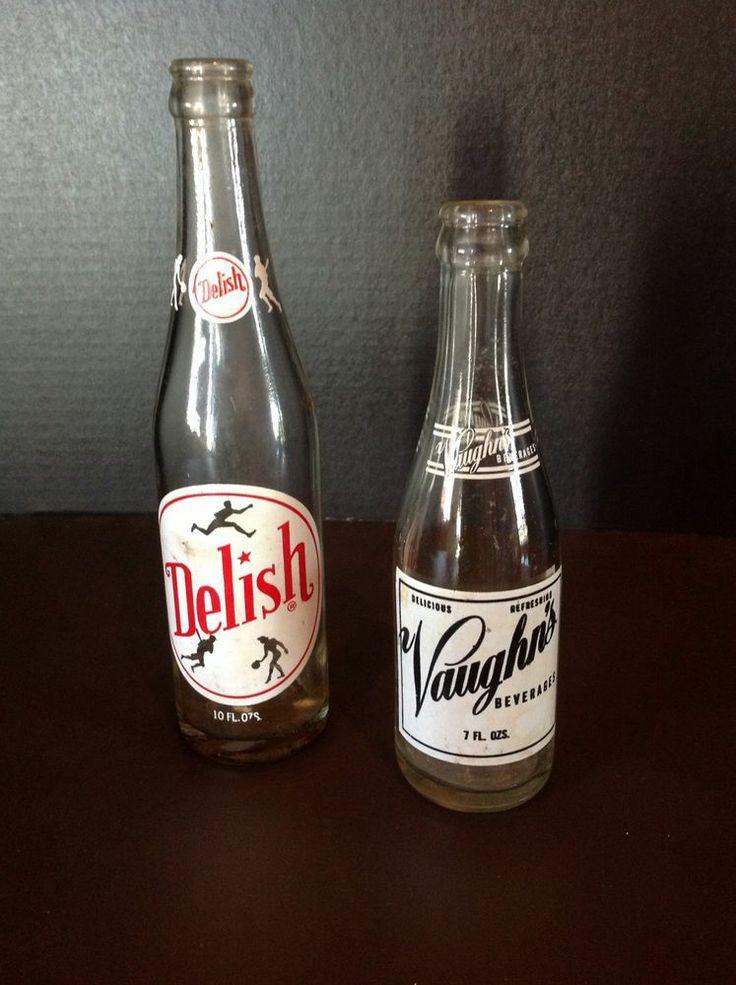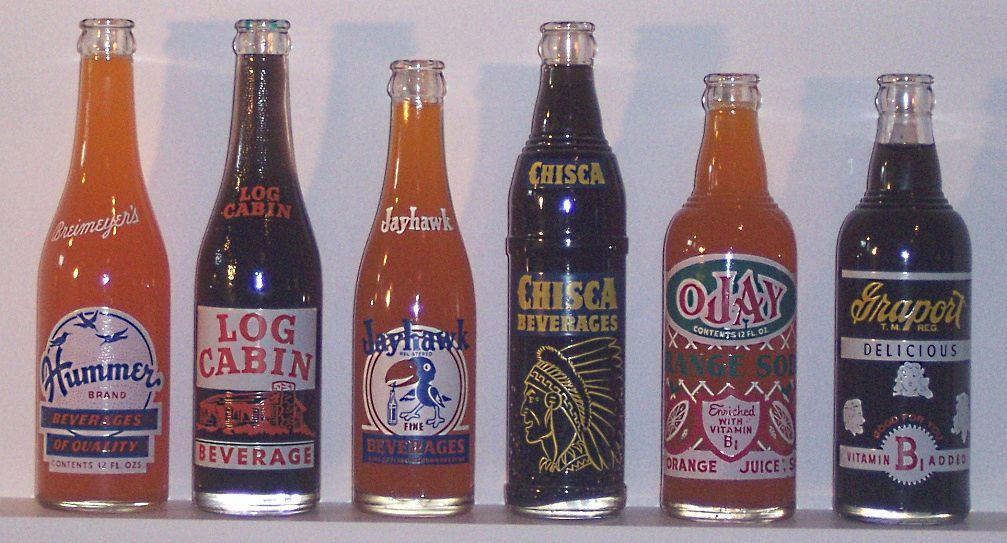The first image is the image on the left, the second image is the image on the right. Examine the images to the left and right. Is the description "At least 5 bottles are standing side by side in one of the pictures." accurate? Answer yes or no. Yes. 